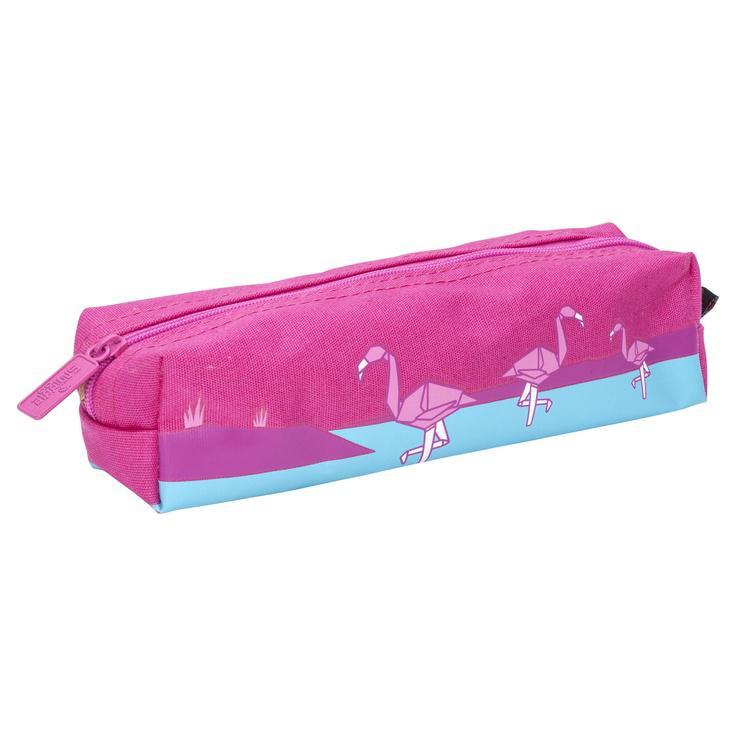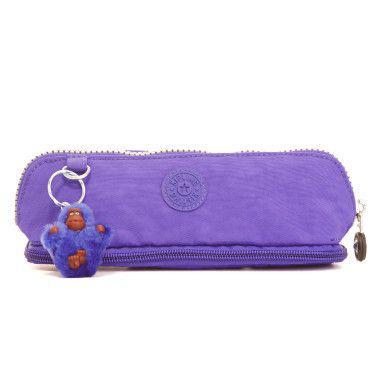The first image is the image on the left, the second image is the image on the right. Analyze the images presented: Is the assertion "There is one purple pencil case and one hot pink pencil case." valid? Answer yes or no. Yes. The first image is the image on the left, the second image is the image on the right. Considering the images on both sides, is "The pencil case in one of the images in purple and the other is pink." valid? Answer yes or no. Yes. 